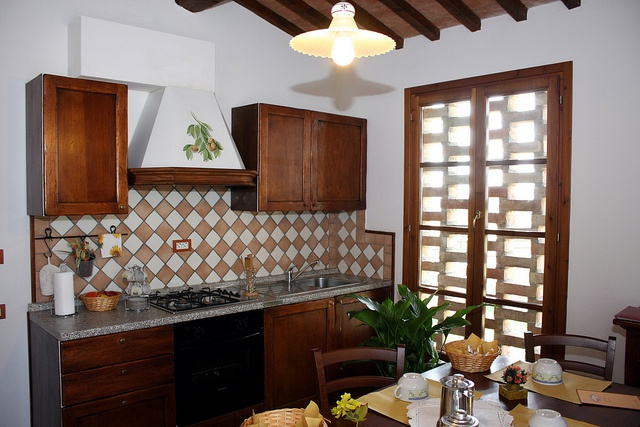Describe the objects in this image and their specific colors. I can see dining table in darkgray, black, olive, and gray tones, oven in darkgray, black, and gray tones, potted plant in darkgray, black, darkgreen, and gray tones, chair in darkgray, black, maroon, and gray tones, and chair in darkgray, black, gray, and maroon tones in this image. 